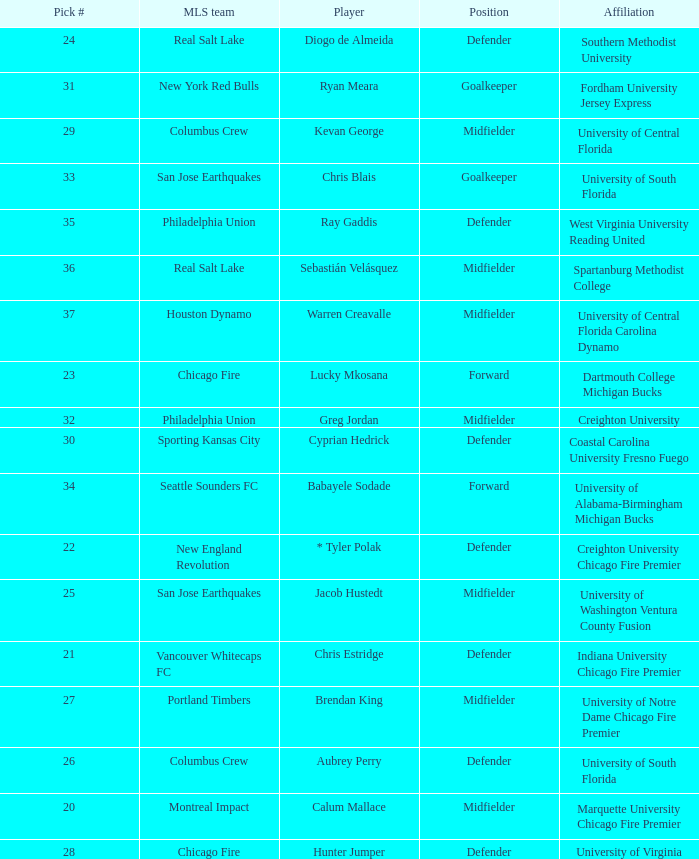What pick number did Real Salt Lake get? 24.0. 